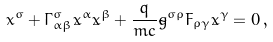<formula> <loc_0><loc_0><loc_500><loc_500>\ddot { x } ^ { \sigma } + { \Gamma } ^ { \sigma } _ { \, \alpha \beta } \dot { x } ^ { \alpha } \dot { x } ^ { \beta } + \frac { q } { m c } \tilde { g } ^ { \sigma \rho } F _ { \rho \gamma } \dot { x } ^ { \gamma } = 0 \, { , }</formula> 